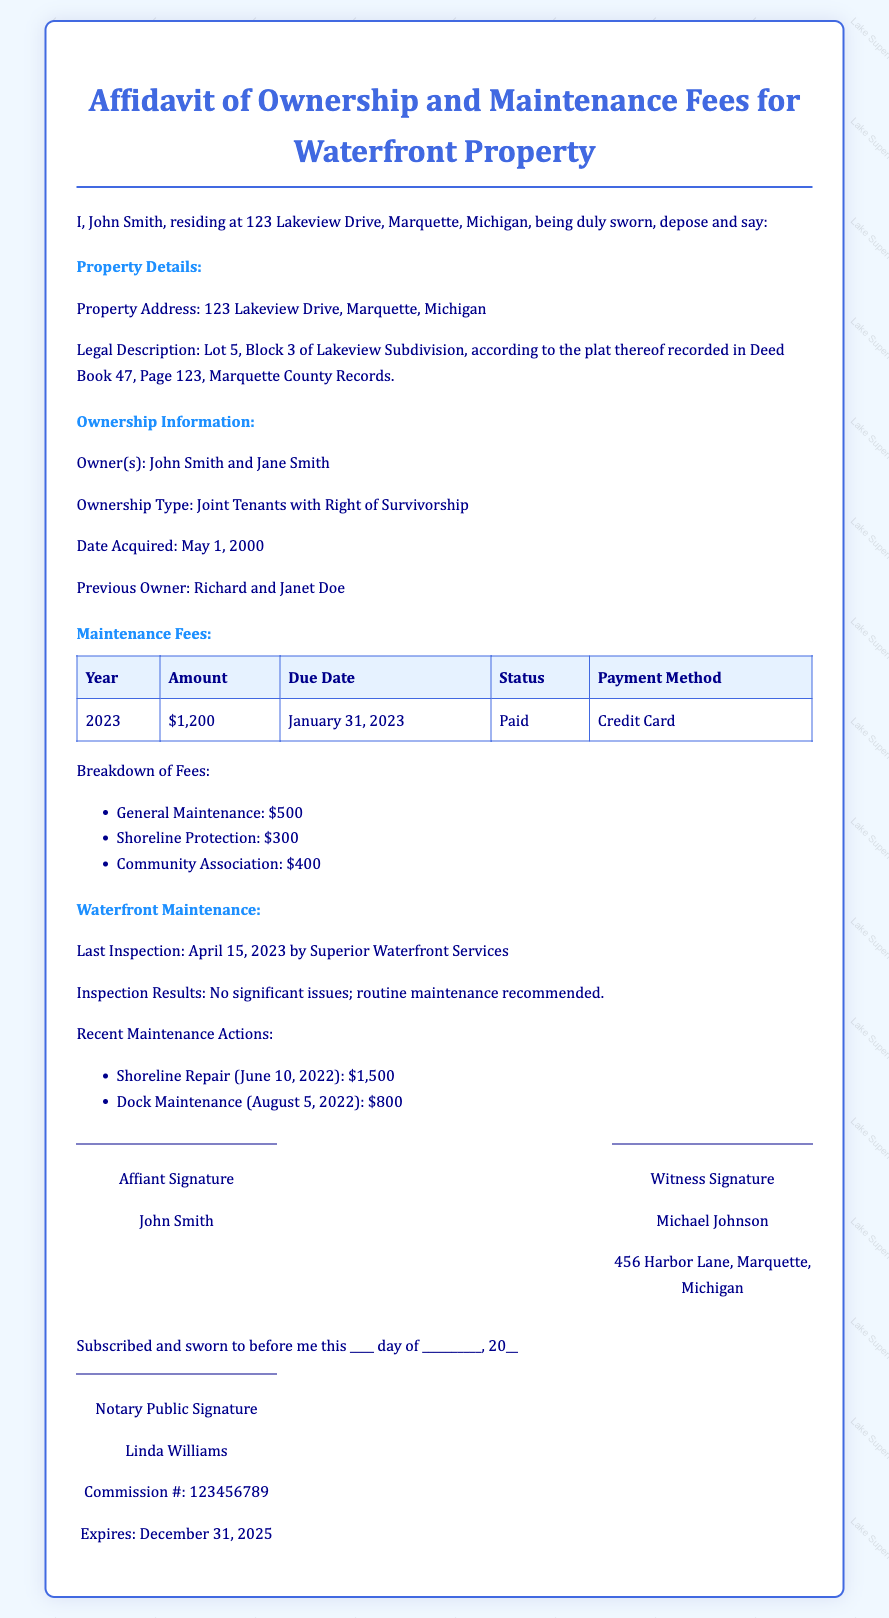What is the name of the owner? The owner's name is stated in the document, which lists "John Smith" as the owner.
Answer: John Smith What is the property address? The property address is provided under Property Details, indicating where the property is located.
Answer: 123 Lakeview Drive, Marquette, Michigan What is the maintenance fee for 2023? The maintenance fee for the year 2023 is listed in the table under Maintenance Fees.
Answer: $1,200 What type of ownership is indicated? The document specifies the type of ownership in the Ownership Information section, mentioning how the property is owned.
Answer: Joint Tenants with Right of Survivorship When was the last inspection conducted? The document states the date of the last inspection for the waterfront maintenance, which is found in the corresponding section.
Answer: April 15, 2023 What were the recent maintenance actions taken? Recent maintenance actions are outlined in the Waterfront Maintenance section, listing the actions and their dates.
Answer: Shoreline Repair and Dock Maintenance Who signed as the witness? The witness signature section includes the name of the individual who witnessed the affidavit.
Answer: Michael Johnson What is the expiration date of the notary's commission? The expiration date for the notary's commission is specified in the notary public section of the document.
Answer: December 31, 2025 